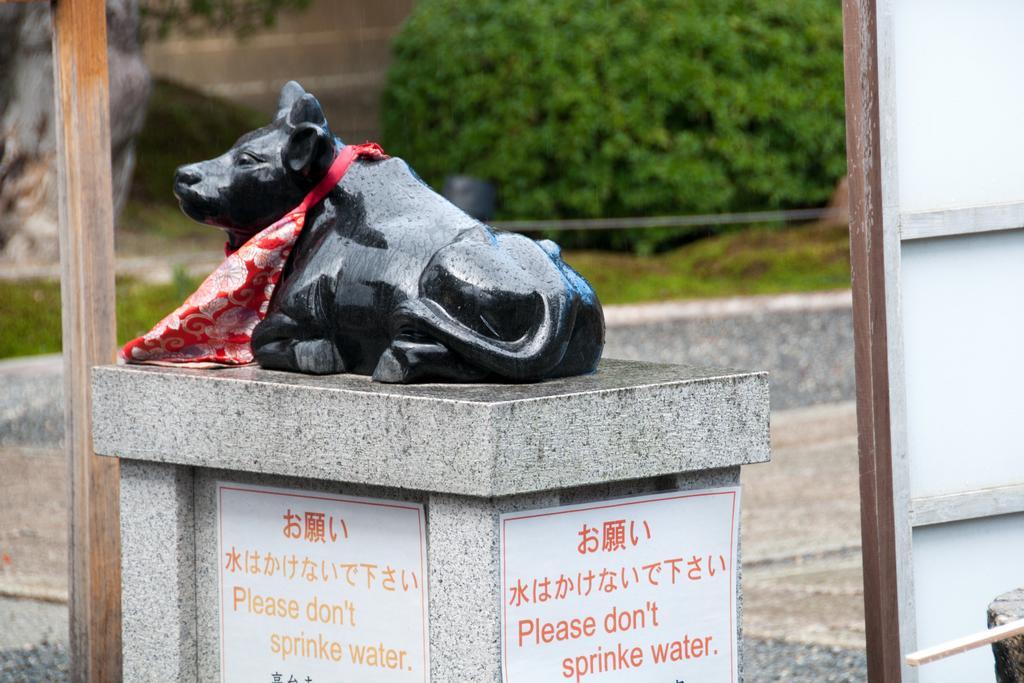How would you summarize this image in a sentence or two? In the image there is a statue of an animal on a marble pillar, behind the statue the background is blurry. 